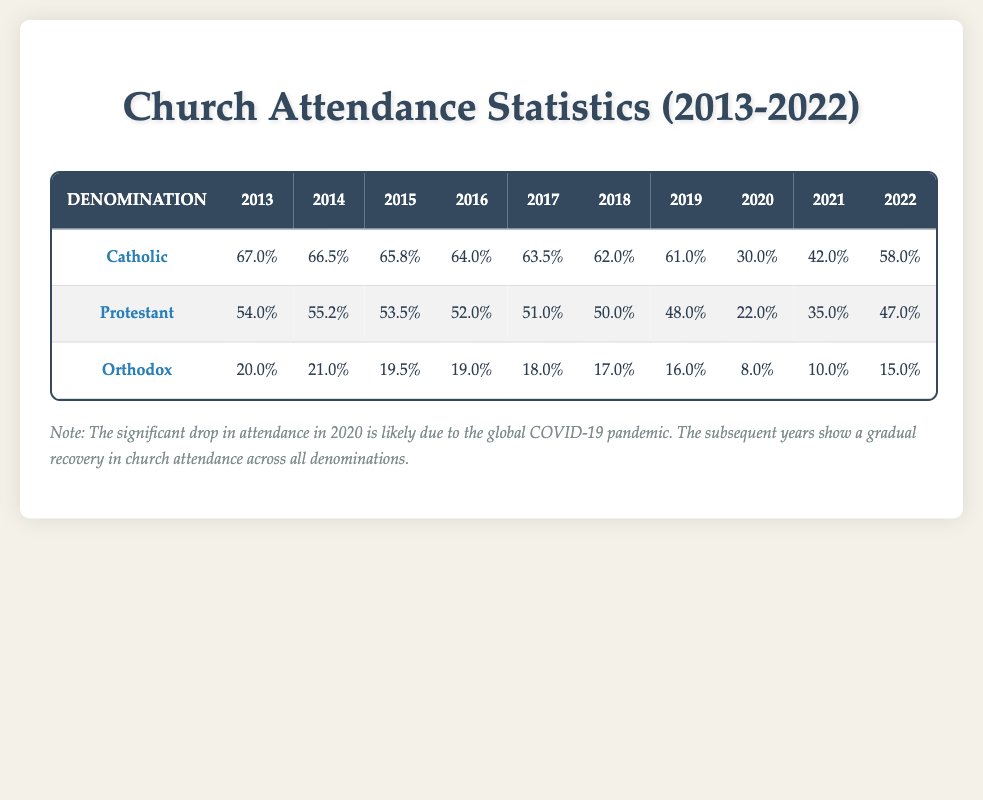What was the highest church attendance percentage recorded for Catholics in the last decade? Referring to the table, the highest attendance for Catholics was in 2013, which is 67.0%.
Answer: 67.0% What year did Orthodox church attendance reach its lowest point in the past decade? Looking at the Orthodox row, the attendance was at its lowest in 2020, with only 8.0%.
Answer: 2020 In which year did Protestant attendance see the most significant decline compared to the previous year? Comparing year to year, the decline from 2019 (48.0%) to 2020 (22.0%) is the largest drop, amounting to 26.0%.
Answer: 2020 What is the average attendance percentage for Catholics from 2013 to 2022? Summing the attendance percentages for Catholics over the years (67.0 + 66.5 + 65.8 + 64.0 + 63.5 + 62.0 + 61.0 + 30.0 + 42.0 + 58.0 =  482.8) and dividing by 10 gives an average of 48.28.
Answer: 48.28 Did the attendance for all denominations recover to their pre-pandemic levels by 2022? Analyzing the data, while Catholic attendance in 2022 (58.0%) did not return to its pre-pandemic level (67.0% in 2013), Protestant attendance (47.0%) and Orthodox attendance (15.0%) also did not recover to pre-pandemic levels (54.0% for Protestant in 2013 and 20.0% for Orthodox in 2013).
Answer: No Which denomination had the highest overall attendance in 2019? Reviewing the data for 2019, the Catholic denomination had the highest attendance at 61.0%, compared to 48.0% for Protestant and 16.0% for Orthodox.
Answer: Catholic What is the total attendance for all denominations in 2021? To find the total for 2021: 42.0% (Catholic) + 35.0% (Protestant) + 10.0% (Orthodox) equals 87.0%.
Answer: 87.0% What percentage did Orthodox attendance drop from 2019 to 2020? From the table, Orthodox attendance in 2019 was 16.0% and in 2020 it dropped to 8.0%. The drop is calculated as 16.0 - 8.0 = 8.0%.
Answer: 8.0% 